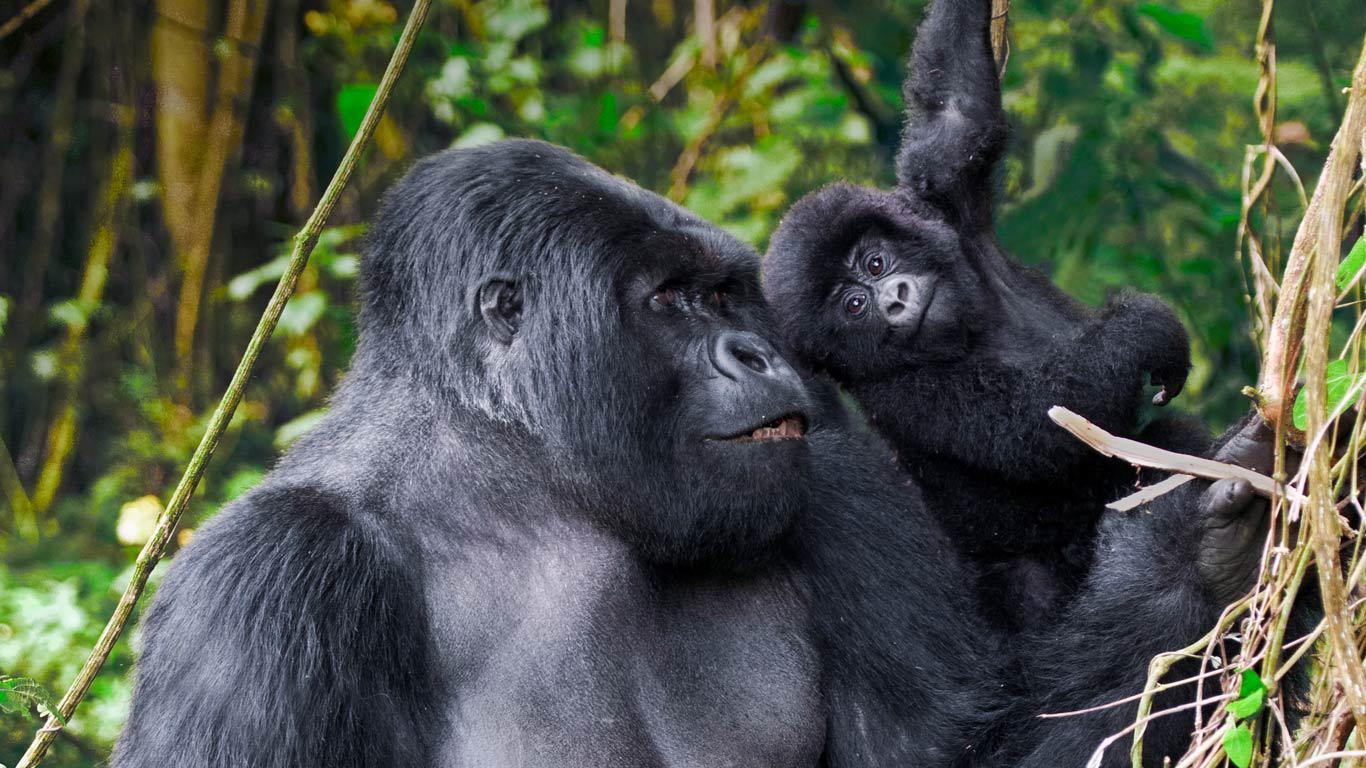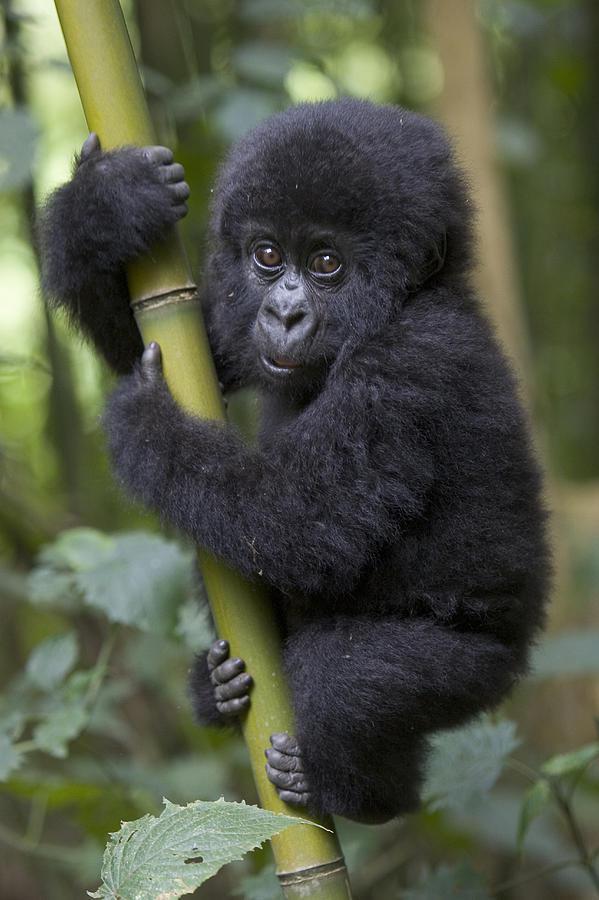The first image is the image on the left, the second image is the image on the right. Given the left and right images, does the statement "The right image shows curled gray fingers pointing toward the head of a forward-facing baby gorilla." hold true? Answer yes or no. Yes. The first image is the image on the left, the second image is the image on the right. Given the left and right images, does the statement "In at least one image there are two gorillas with one adult holding a single baby." hold true? Answer yes or no. Yes. 